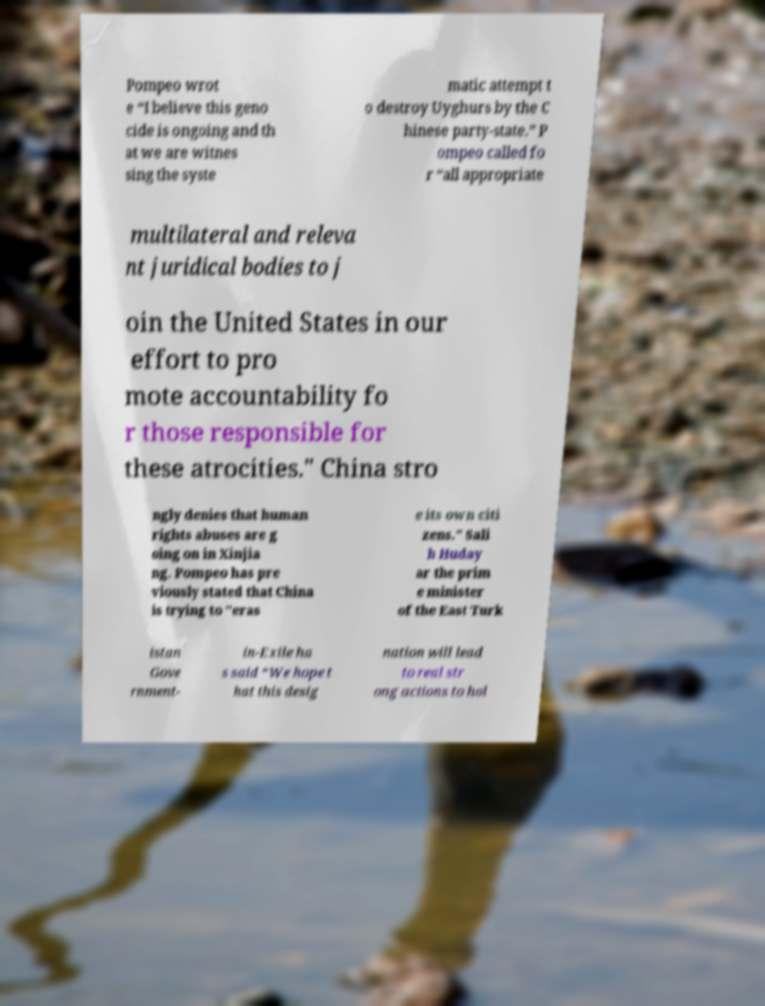There's text embedded in this image that I need extracted. Can you transcribe it verbatim? Pompeo wrot e “I believe this geno cide is ongoing and th at we are witnes sing the syste matic attempt t o destroy Uyghurs by the C hinese party-state.” P ompeo called fo r “all appropriate multilateral and releva nt juridical bodies to j oin the United States in our effort to pro mote accountability fo r those responsible for these atrocities." China stro ngly denies that human rights abuses are g oing on in Xinjia ng. Pompeo has pre viously stated that China is trying to "eras e its own citi zens." Sali h Huday ar the prim e minister of the East Turk istan Gove rnment- in-Exile ha s said “We hope t hat this desig nation will lead to real str ong actions to hol 